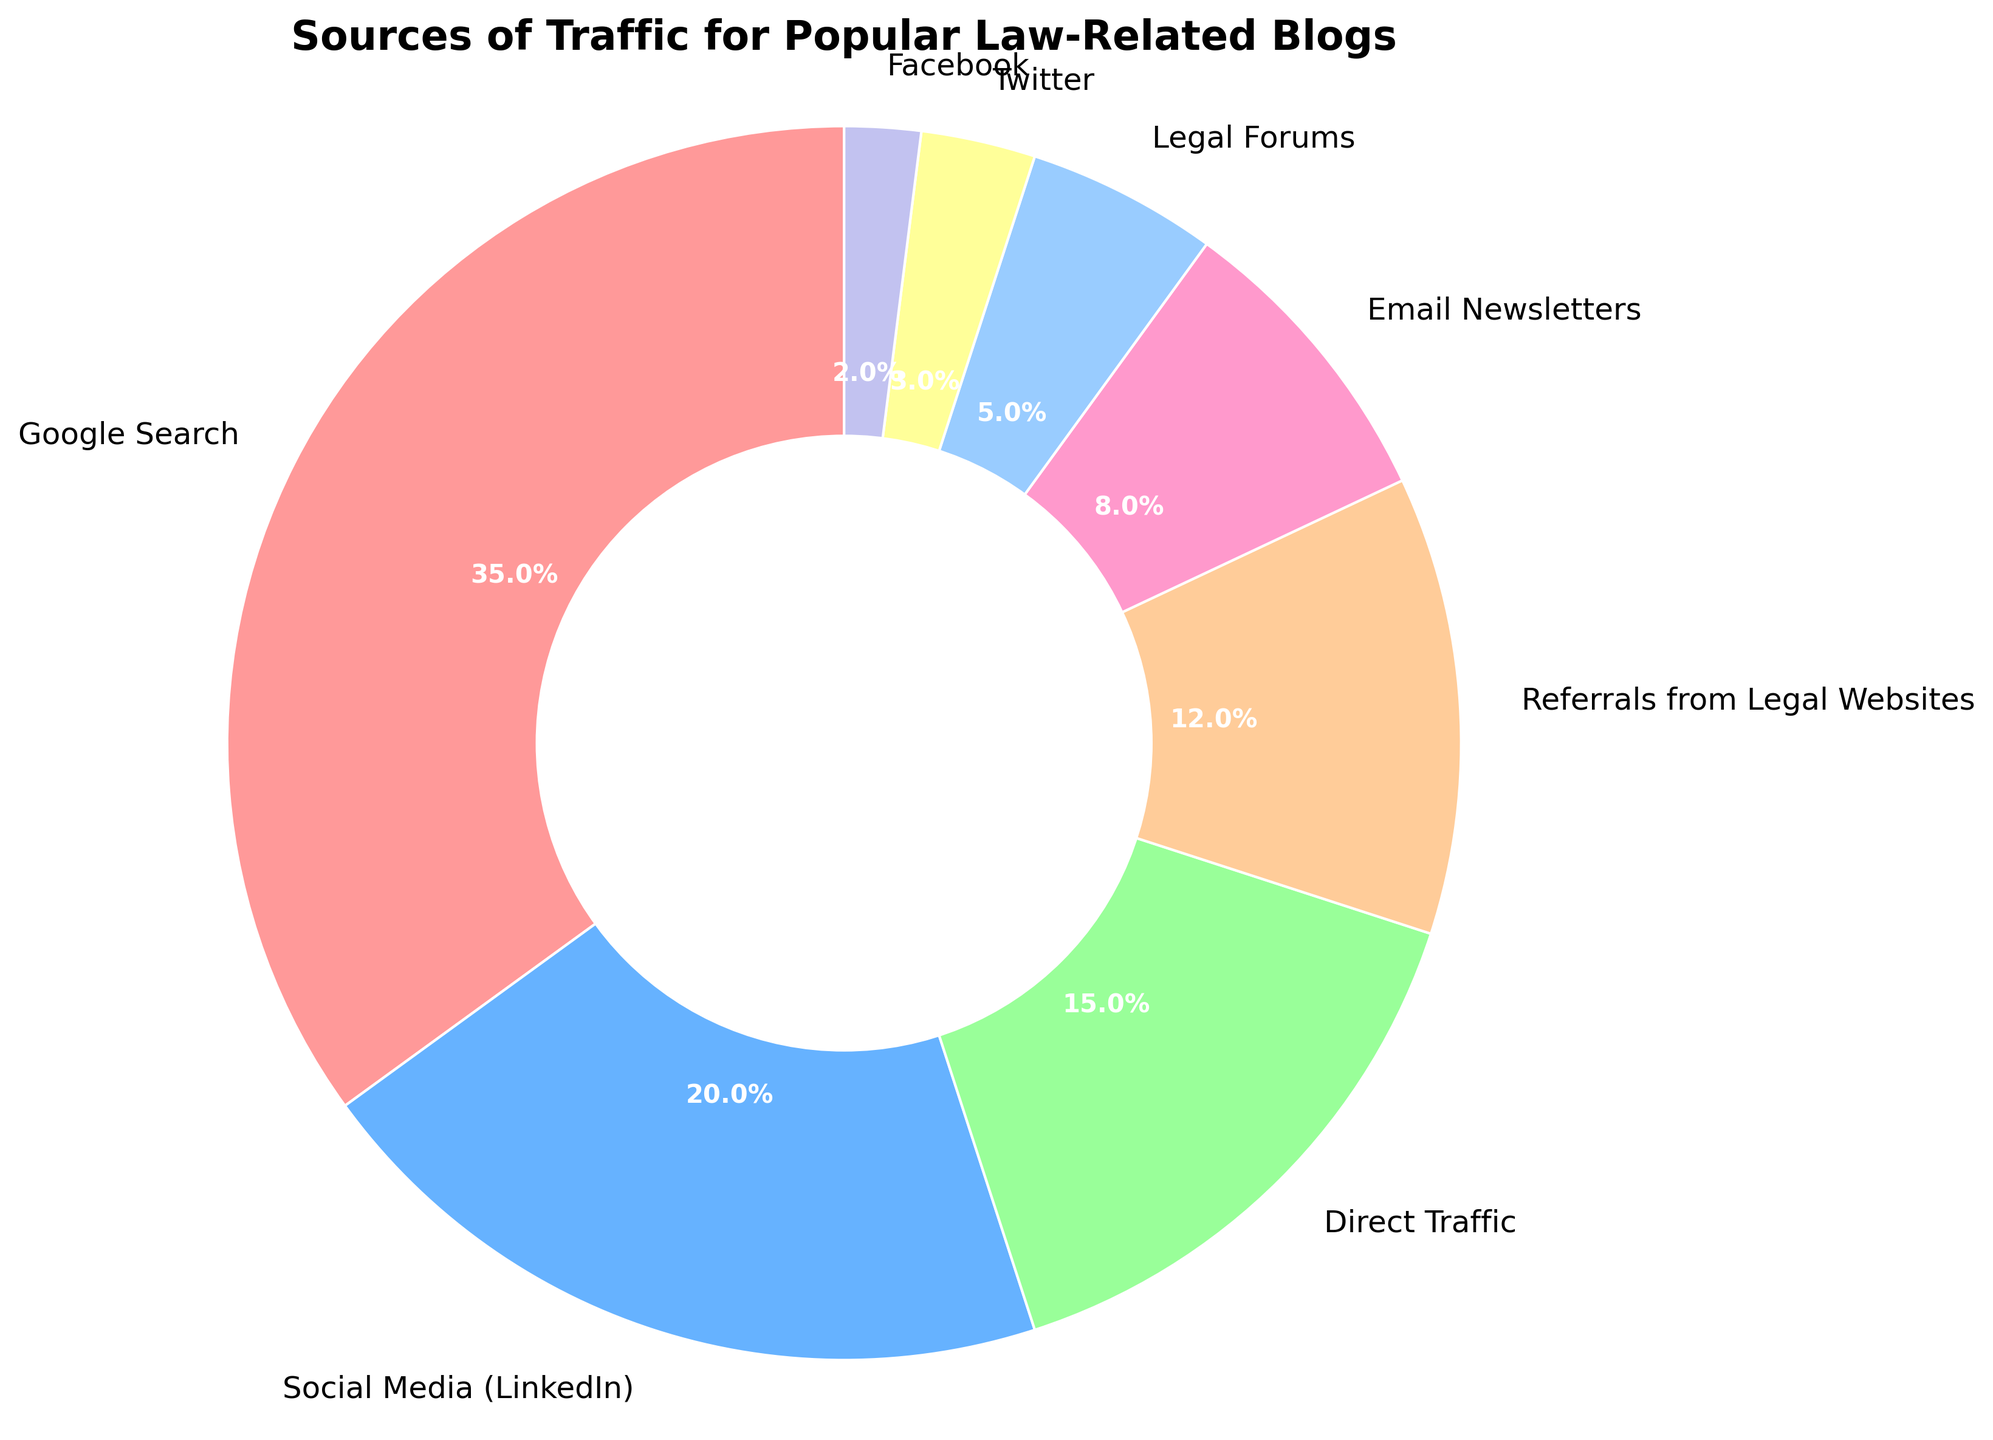What is the largest source of traffic for popular law-related blogs? The largest slice of the pie chart represents the largest source of traffic. This slice is labeled "Google Search" with 35%.
Answer: Google Search Which source has a higher percentage of traffic, Social Media (LinkedIn) or Direct Traffic? Compare the slices for Social Media (LinkedIn) and Direct Traffic. Social Media (LinkedIn) has a 20% share, and Direct Traffic has a 15% share. 20% > 15%.
Answer: Social Media (LinkedIn) What is the combined traffic percentage from Email Newsletters and Legal Forums? Add the percentages for Email Newsletters and Legal Forums. Email Newsletters is 8% and Legal Forums is 5%. 8% + 5% = 13%.
Answer: 13% Which source has the smallest traffic percentage and what is it? The smallest slice in the pie chart is labeled "Facebook" with 2%.
Answer: Facebook, 2% Is Twitter's traffic share larger than Facebook's? Compare the slice sizes for Twitter and Facebook. Twitter has a 3% traffic share, while Facebook has a 2% traffic share. 3% > 2%.
Answer: Yes How much more traffic does Google Search generate compared to Referrals from Legal Websites? Subtract the percentage of Referrals from Legal Websites from the percentage of Google Search. Google Search is 35%, and Referrals from Legal Websites is 12%. 35% - 12% = 23%.
Answer: 23% What is the total percentage of traffic coming from social media platforms (LinkedIn, Twitter, Facebook)? Add the percentages for LinkedIn, Twitter, and Facebook. LinkedIn is 20%, Twitter is 3%, and Facebook is 2%. 20% + 3% + 2% = 25%.
Answer: 25% Rank the sources from highest to lowest traffic. List the sources based on their percentages: 1. Google Search (35%), 2. Social Media (LinkedIn) (20%), 3. Direct Traffic (15%), 4. Referrals from Legal Websites (12%), 5. Email Newsletters (8%), 6. Legal Forums (5%), 7. Twitter (3%), 8. Facebook (2%).
Answer: Google Search, Social Media (LinkedIn), Direct Traffic, Referrals from Legal Websites, Email Newsletters, Legal Forums, Twitter, Facebook What is the average traffic percentage of all sources? Sum up all the percentages and divide by the number of sources. The total percentage is 35% + 20% + 15% + 12% + 8% + 5% + 3% + 2% = 100%. There are 8 sources. The average is 100% / 8 = 12.5%.
Answer: 12.5% Which category's slice is light blue in the pie chart? The light blue slice corresponds to the category labeled "Social Media (LinkedIn)".
Answer: Social Media (LinkedIn) 